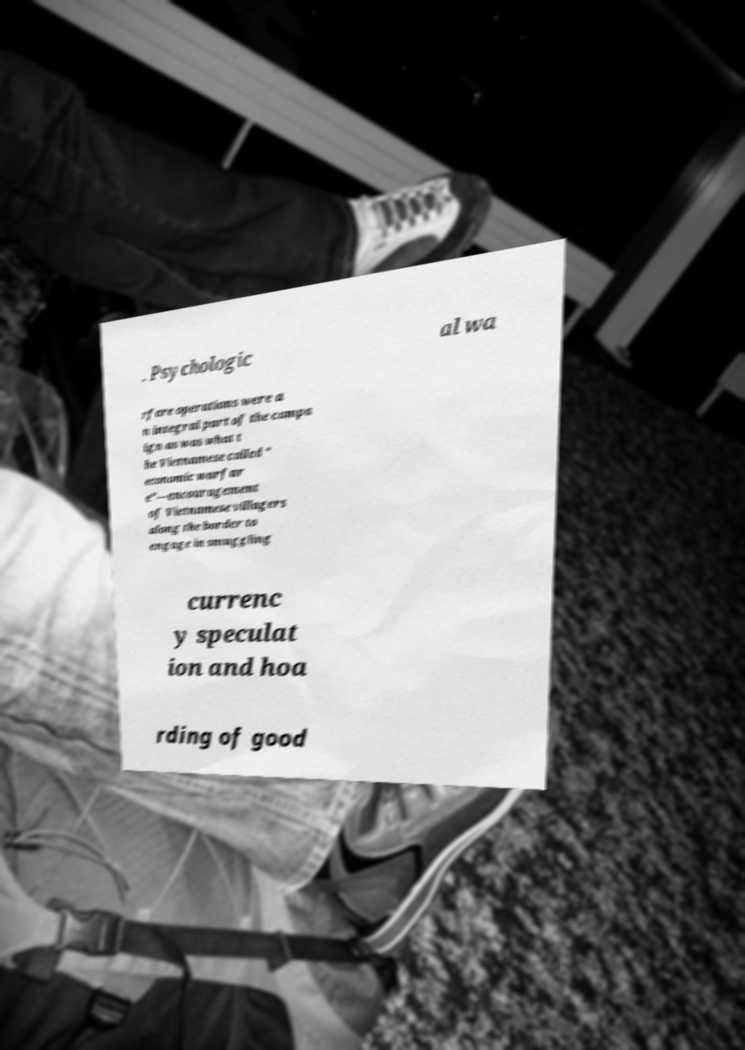What messages or text are displayed in this image? I need them in a readable, typed format. . Psychologic al wa rfare operations were a n integral part of the campa ign as was what t he Vietnamese called " economic warfar e"—encouragement of Vietnamese villagers along the border to engage in smuggling currenc y speculat ion and hoa rding of good 